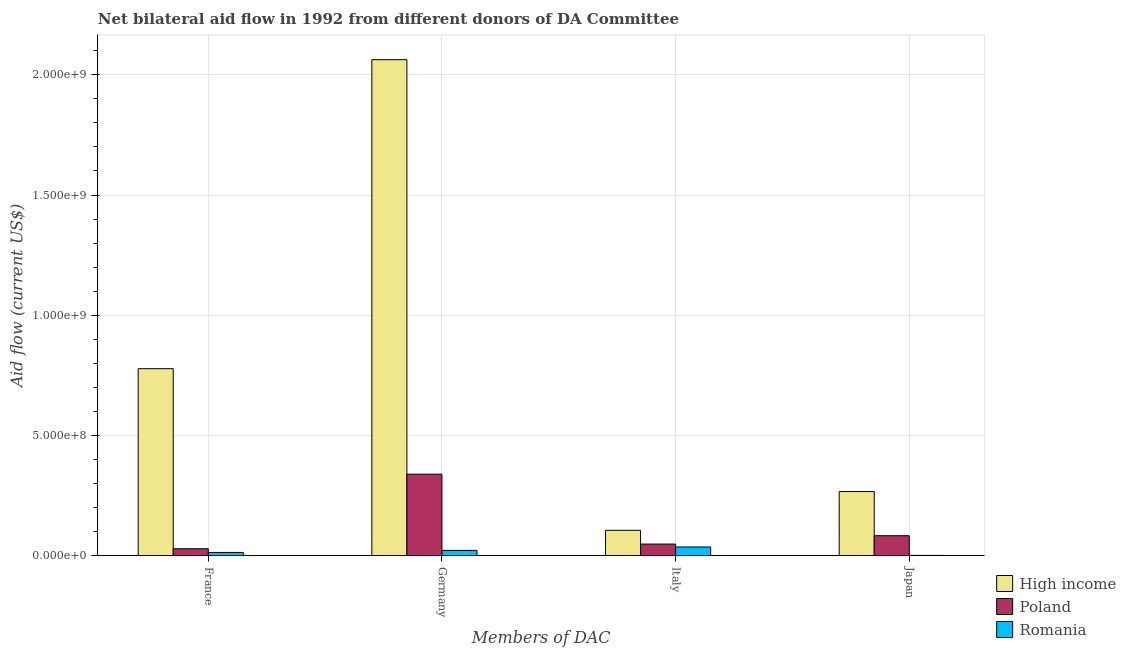How many different coloured bars are there?
Provide a short and direct response. 3. How many groups of bars are there?
Give a very brief answer. 4. Are the number of bars per tick equal to the number of legend labels?
Offer a terse response. Yes. Are the number of bars on each tick of the X-axis equal?
Make the answer very short. Yes. How many bars are there on the 2nd tick from the left?
Give a very brief answer. 3. What is the amount of aid given by germany in Romania?
Ensure brevity in your answer.  2.25e+07. Across all countries, what is the maximum amount of aid given by italy?
Your answer should be compact. 1.06e+08. Across all countries, what is the minimum amount of aid given by italy?
Your response must be concise. 3.67e+07. In which country was the amount of aid given by germany minimum?
Your answer should be compact. Romania. What is the total amount of aid given by italy in the graph?
Provide a short and direct response. 1.91e+08. What is the difference between the amount of aid given by italy in High income and that in Poland?
Provide a short and direct response. 5.71e+07. What is the difference between the amount of aid given by japan in High income and the amount of aid given by germany in Romania?
Provide a short and direct response. 2.45e+08. What is the average amount of aid given by france per country?
Provide a succinct answer. 2.74e+08. What is the difference between the amount of aid given by japan and amount of aid given by france in High income?
Offer a terse response. -5.11e+08. What is the ratio of the amount of aid given by france in High income to that in Romania?
Ensure brevity in your answer.  55.8. Is the amount of aid given by italy in Romania less than that in High income?
Offer a very short reply. Yes. What is the difference between the highest and the second highest amount of aid given by germany?
Keep it short and to the point. 1.72e+09. What is the difference between the highest and the lowest amount of aid given by france?
Provide a short and direct response. 7.64e+08. In how many countries, is the amount of aid given by france greater than the average amount of aid given by france taken over all countries?
Make the answer very short. 1. What does the 3rd bar from the left in Italy represents?
Provide a succinct answer. Romania. Is it the case that in every country, the sum of the amount of aid given by france and amount of aid given by germany is greater than the amount of aid given by italy?
Your response must be concise. No. Where does the legend appear in the graph?
Offer a terse response. Bottom right. How many legend labels are there?
Make the answer very short. 3. What is the title of the graph?
Offer a very short reply. Net bilateral aid flow in 1992 from different donors of DA Committee. Does "Indonesia" appear as one of the legend labels in the graph?
Provide a short and direct response. No. What is the label or title of the X-axis?
Offer a very short reply. Members of DAC. What is the label or title of the Y-axis?
Make the answer very short. Aid flow (current US$). What is the Aid flow (current US$) in High income in France?
Ensure brevity in your answer.  7.78e+08. What is the Aid flow (current US$) of Poland in France?
Your answer should be compact. 2.92e+07. What is the Aid flow (current US$) in Romania in France?
Make the answer very short. 1.39e+07. What is the Aid flow (current US$) in High income in Germany?
Your response must be concise. 2.06e+09. What is the Aid flow (current US$) of Poland in Germany?
Offer a very short reply. 3.39e+08. What is the Aid flow (current US$) in Romania in Germany?
Offer a terse response. 2.25e+07. What is the Aid flow (current US$) of High income in Italy?
Offer a very short reply. 1.06e+08. What is the Aid flow (current US$) of Poland in Italy?
Your answer should be compact. 4.87e+07. What is the Aid flow (current US$) of Romania in Italy?
Give a very brief answer. 3.67e+07. What is the Aid flow (current US$) of High income in Japan?
Your answer should be compact. 2.67e+08. What is the Aid flow (current US$) in Poland in Japan?
Provide a short and direct response. 8.35e+07. What is the Aid flow (current US$) of Romania in Japan?
Keep it short and to the point. 1.78e+06. Across all Members of DAC, what is the maximum Aid flow (current US$) of High income?
Your answer should be very brief. 2.06e+09. Across all Members of DAC, what is the maximum Aid flow (current US$) of Poland?
Offer a terse response. 3.39e+08. Across all Members of DAC, what is the maximum Aid flow (current US$) of Romania?
Offer a very short reply. 3.67e+07. Across all Members of DAC, what is the minimum Aid flow (current US$) in High income?
Your response must be concise. 1.06e+08. Across all Members of DAC, what is the minimum Aid flow (current US$) of Poland?
Offer a terse response. 2.92e+07. Across all Members of DAC, what is the minimum Aid flow (current US$) in Romania?
Provide a succinct answer. 1.78e+06. What is the total Aid flow (current US$) of High income in the graph?
Keep it short and to the point. 3.21e+09. What is the total Aid flow (current US$) of Poland in the graph?
Provide a short and direct response. 5.01e+08. What is the total Aid flow (current US$) of Romania in the graph?
Your answer should be very brief. 7.49e+07. What is the difference between the Aid flow (current US$) in High income in France and that in Germany?
Keep it short and to the point. -1.28e+09. What is the difference between the Aid flow (current US$) in Poland in France and that in Germany?
Provide a short and direct response. -3.10e+08. What is the difference between the Aid flow (current US$) in Romania in France and that in Germany?
Your response must be concise. -8.56e+06. What is the difference between the Aid flow (current US$) of High income in France and that in Italy?
Provide a succinct answer. 6.72e+08. What is the difference between the Aid flow (current US$) in Poland in France and that in Italy?
Give a very brief answer. -1.95e+07. What is the difference between the Aid flow (current US$) in Romania in France and that in Italy?
Make the answer very short. -2.27e+07. What is the difference between the Aid flow (current US$) in High income in France and that in Japan?
Offer a very short reply. 5.11e+08. What is the difference between the Aid flow (current US$) of Poland in France and that in Japan?
Offer a very short reply. -5.43e+07. What is the difference between the Aid flow (current US$) of Romania in France and that in Japan?
Give a very brief answer. 1.22e+07. What is the difference between the Aid flow (current US$) in High income in Germany and that in Italy?
Ensure brevity in your answer.  1.96e+09. What is the difference between the Aid flow (current US$) of Poland in Germany and that in Italy?
Offer a terse response. 2.91e+08. What is the difference between the Aid flow (current US$) of Romania in Germany and that in Italy?
Your answer should be compact. -1.42e+07. What is the difference between the Aid flow (current US$) of High income in Germany and that in Japan?
Give a very brief answer. 1.80e+09. What is the difference between the Aid flow (current US$) in Poland in Germany and that in Japan?
Ensure brevity in your answer.  2.56e+08. What is the difference between the Aid flow (current US$) in Romania in Germany and that in Japan?
Give a very brief answer. 2.07e+07. What is the difference between the Aid flow (current US$) in High income in Italy and that in Japan?
Your response must be concise. -1.61e+08. What is the difference between the Aid flow (current US$) in Poland in Italy and that in Japan?
Keep it short and to the point. -3.48e+07. What is the difference between the Aid flow (current US$) in Romania in Italy and that in Japan?
Make the answer very short. 3.49e+07. What is the difference between the Aid flow (current US$) of High income in France and the Aid flow (current US$) of Poland in Germany?
Keep it short and to the point. 4.38e+08. What is the difference between the Aid flow (current US$) of High income in France and the Aid flow (current US$) of Romania in Germany?
Provide a succinct answer. 7.55e+08. What is the difference between the Aid flow (current US$) in Poland in France and the Aid flow (current US$) in Romania in Germany?
Provide a short and direct response. 6.72e+06. What is the difference between the Aid flow (current US$) of High income in France and the Aid flow (current US$) of Poland in Italy?
Offer a terse response. 7.29e+08. What is the difference between the Aid flow (current US$) in High income in France and the Aid flow (current US$) in Romania in Italy?
Offer a very short reply. 7.41e+08. What is the difference between the Aid flow (current US$) of Poland in France and the Aid flow (current US$) of Romania in Italy?
Keep it short and to the point. -7.45e+06. What is the difference between the Aid flow (current US$) of High income in France and the Aid flow (current US$) of Poland in Japan?
Offer a very short reply. 6.94e+08. What is the difference between the Aid flow (current US$) in High income in France and the Aid flow (current US$) in Romania in Japan?
Your response must be concise. 7.76e+08. What is the difference between the Aid flow (current US$) in Poland in France and the Aid flow (current US$) in Romania in Japan?
Keep it short and to the point. 2.74e+07. What is the difference between the Aid flow (current US$) in High income in Germany and the Aid flow (current US$) in Poland in Italy?
Offer a very short reply. 2.01e+09. What is the difference between the Aid flow (current US$) in High income in Germany and the Aid flow (current US$) in Romania in Italy?
Your answer should be compact. 2.03e+09. What is the difference between the Aid flow (current US$) in Poland in Germany and the Aid flow (current US$) in Romania in Italy?
Keep it short and to the point. 3.03e+08. What is the difference between the Aid flow (current US$) of High income in Germany and the Aid flow (current US$) of Poland in Japan?
Give a very brief answer. 1.98e+09. What is the difference between the Aid flow (current US$) of High income in Germany and the Aid flow (current US$) of Romania in Japan?
Your response must be concise. 2.06e+09. What is the difference between the Aid flow (current US$) of Poland in Germany and the Aid flow (current US$) of Romania in Japan?
Ensure brevity in your answer.  3.38e+08. What is the difference between the Aid flow (current US$) of High income in Italy and the Aid flow (current US$) of Poland in Japan?
Your answer should be compact. 2.24e+07. What is the difference between the Aid flow (current US$) in High income in Italy and the Aid flow (current US$) in Romania in Japan?
Make the answer very short. 1.04e+08. What is the difference between the Aid flow (current US$) of Poland in Italy and the Aid flow (current US$) of Romania in Japan?
Ensure brevity in your answer.  4.70e+07. What is the average Aid flow (current US$) in High income per Members of DAC?
Offer a terse response. 8.03e+08. What is the average Aid flow (current US$) in Poland per Members of DAC?
Ensure brevity in your answer.  1.25e+08. What is the average Aid flow (current US$) in Romania per Members of DAC?
Make the answer very short. 1.87e+07. What is the difference between the Aid flow (current US$) in High income and Aid flow (current US$) in Poland in France?
Provide a short and direct response. 7.49e+08. What is the difference between the Aid flow (current US$) in High income and Aid flow (current US$) in Romania in France?
Offer a terse response. 7.64e+08. What is the difference between the Aid flow (current US$) in Poland and Aid flow (current US$) in Romania in France?
Your answer should be compact. 1.53e+07. What is the difference between the Aid flow (current US$) in High income and Aid flow (current US$) in Poland in Germany?
Offer a terse response. 1.72e+09. What is the difference between the Aid flow (current US$) of High income and Aid flow (current US$) of Romania in Germany?
Provide a succinct answer. 2.04e+09. What is the difference between the Aid flow (current US$) of Poland and Aid flow (current US$) of Romania in Germany?
Your response must be concise. 3.17e+08. What is the difference between the Aid flow (current US$) in High income and Aid flow (current US$) in Poland in Italy?
Keep it short and to the point. 5.71e+07. What is the difference between the Aid flow (current US$) in High income and Aid flow (current US$) in Romania in Italy?
Provide a short and direct response. 6.92e+07. What is the difference between the Aid flow (current US$) of Poland and Aid flow (current US$) of Romania in Italy?
Give a very brief answer. 1.21e+07. What is the difference between the Aid flow (current US$) of High income and Aid flow (current US$) of Poland in Japan?
Give a very brief answer. 1.84e+08. What is the difference between the Aid flow (current US$) of High income and Aid flow (current US$) of Romania in Japan?
Keep it short and to the point. 2.65e+08. What is the difference between the Aid flow (current US$) in Poland and Aid flow (current US$) in Romania in Japan?
Offer a terse response. 8.17e+07. What is the ratio of the Aid flow (current US$) of High income in France to that in Germany?
Provide a short and direct response. 0.38. What is the ratio of the Aid flow (current US$) in Poland in France to that in Germany?
Your answer should be very brief. 0.09. What is the ratio of the Aid flow (current US$) of Romania in France to that in Germany?
Your response must be concise. 0.62. What is the ratio of the Aid flow (current US$) in High income in France to that in Italy?
Offer a very short reply. 7.35. What is the ratio of the Aid flow (current US$) of Poland in France to that in Italy?
Your response must be concise. 0.6. What is the ratio of the Aid flow (current US$) in Romania in France to that in Italy?
Offer a very short reply. 0.38. What is the ratio of the Aid flow (current US$) of High income in France to that in Japan?
Your answer should be very brief. 2.91. What is the ratio of the Aid flow (current US$) in Romania in France to that in Japan?
Offer a terse response. 7.83. What is the ratio of the Aid flow (current US$) in High income in Germany to that in Italy?
Your answer should be compact. 19.48. What is the ratio of the Aid flow (current US$) in Poland in Germany to that in Italy?
Offer a very short reply. 6.96. What is the ratio of the Aid flow (current US$) of Romania in Germany to that in Italy?
Keep it short and to the point. 0.61. What is the ratio of the Aid flow (current US$) of High income in Germany to that in Japan?
Make the answer very short. 7.72. What is the ratio of the Aid flow (current US$) of Poland in Germany to that in Japan?
Keep it short and to the point. 4.07. What is the ratio of the Aid flow (current US$) in Romania in Germany to that in Japan?
Your answer should be compact. 12.64. What is the ratio of the Aid flow (current US$) of High income in Italy to that in Japan?
Your answer should be compact. 0.4. What is the ratio of the Aid flow (current US$) of Poland in Italy to that in Japan?
Offer a very short reply. 0.58. What is the ratio of the Aid flow (current US$) in Romania in Italy to that in Japan?
Offer a very short reply. 20.6. What is the difference between the highest and the second highest Aid flow (current US$) in High income?
Your answer should be very brief. 1.28e+09. What is the difference between the highest and the second highest Aid flow (current US$) in Poland?
Provide a short and direct response. 2.56e+08. What is the difference between the highest and the second highest Aid flow (current US$) in Romania?
Make the answer very short. 1.42e+07. What is the difference between the highest and the lowest Aid flow (current US$) in High income?
Keep it short and to the point. 1.96e+09. What is the difference between the highest and the lowest Aid flow (current US$) of Poland?
Offer a very short reply. 3.10e+08. What is the difference between the highest and the lowest Aid flow (current US$) of Romania?
Give a very brief answer. 3.49e+07. 